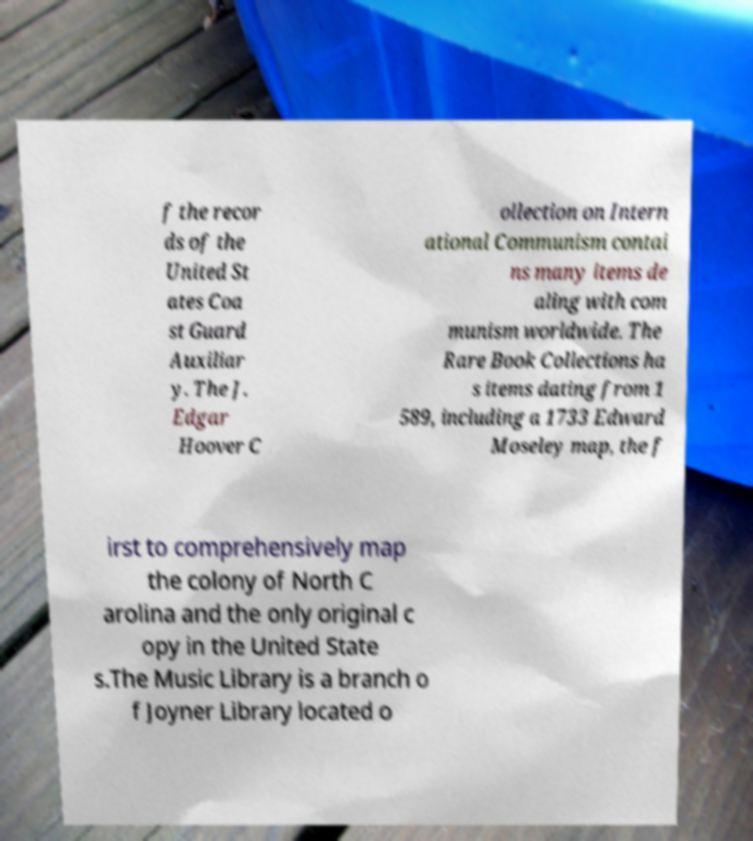What messages or text are displayed in this image? I need them in a readable, typed format. f the recor ds of the United St ates Coa st Guard Auxiliar y. The J. Edgar Hoover C ollection on Intern ational Communism contai ns many items de aling with com munism worldwide. The Rare Book Collections ha s items dating from 1 589, including a 1733 Edward Moseley map, the f irst to comprehensively map the colony of North C arolina and the only original c opy in the United State s.The Music Library is a branch o f Joyner Library located o 